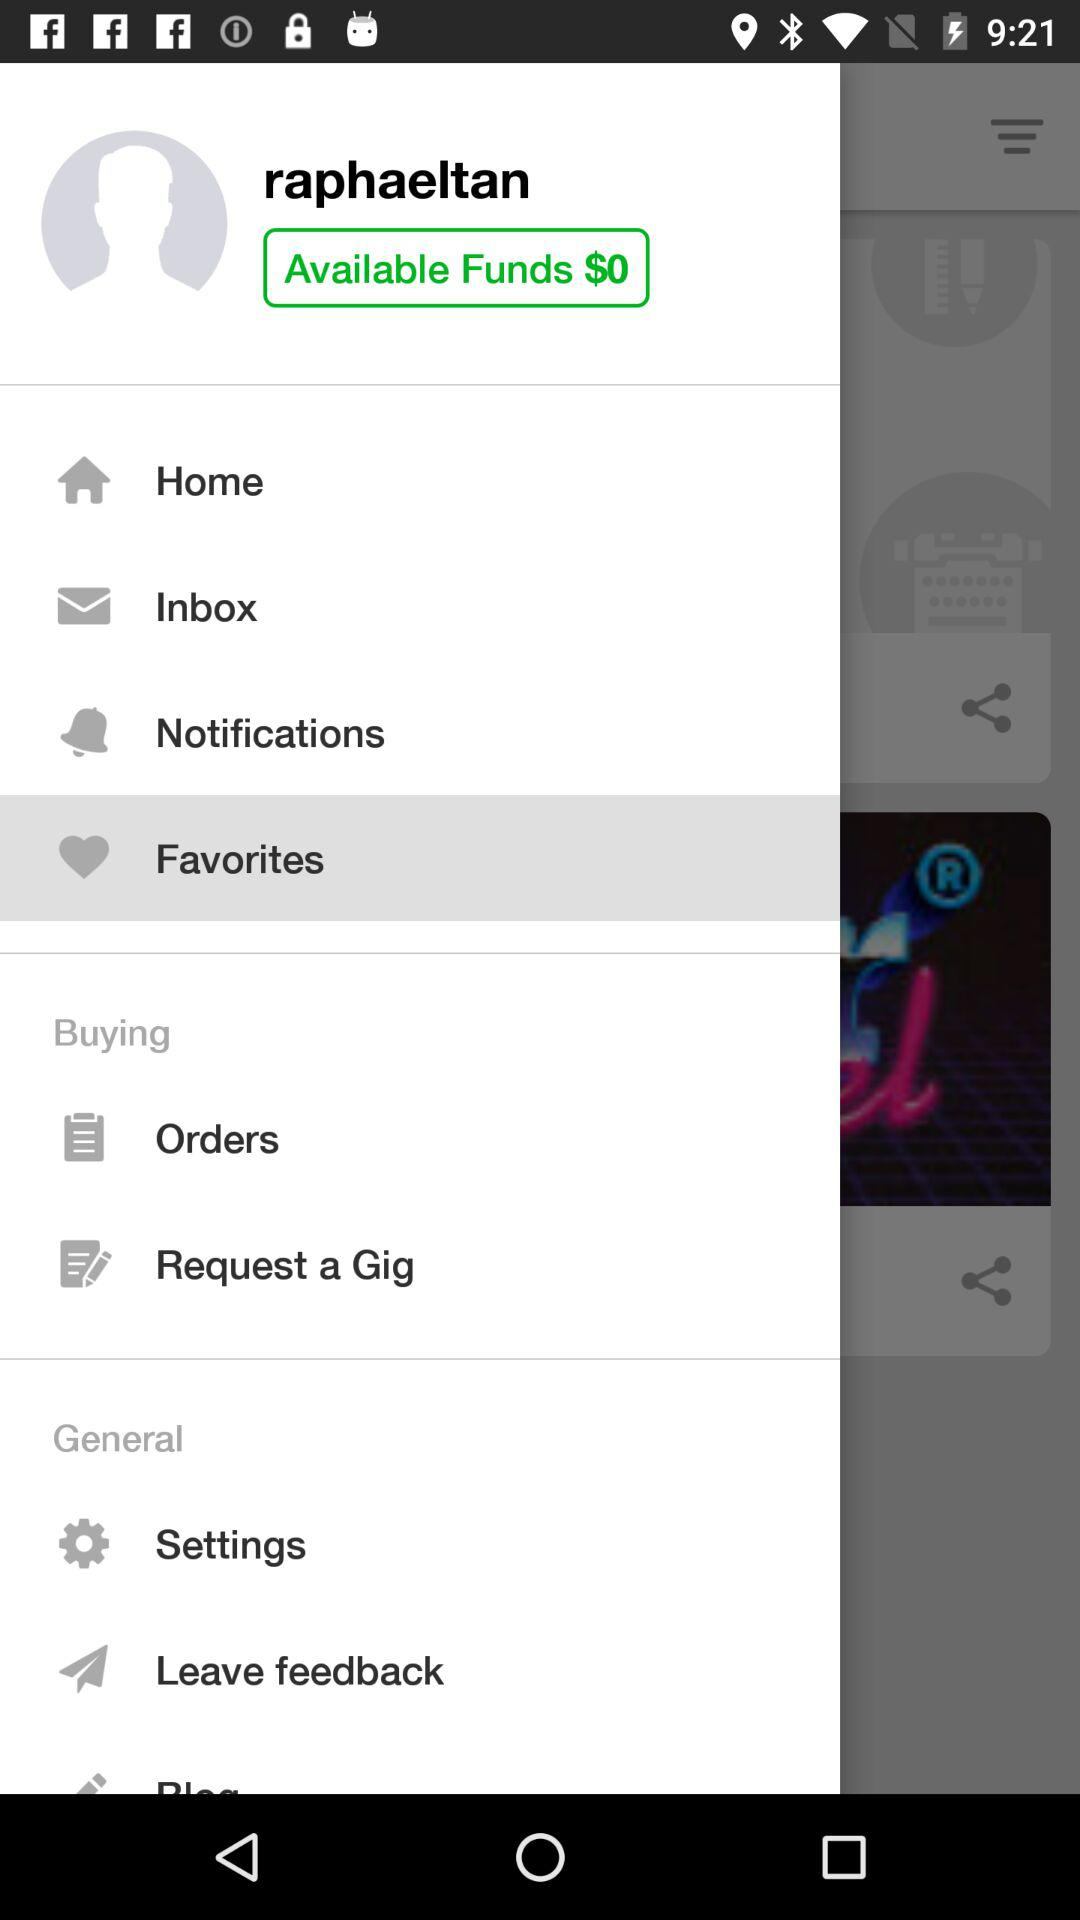What is the name of the user? The name of the user is raphaeltan. 